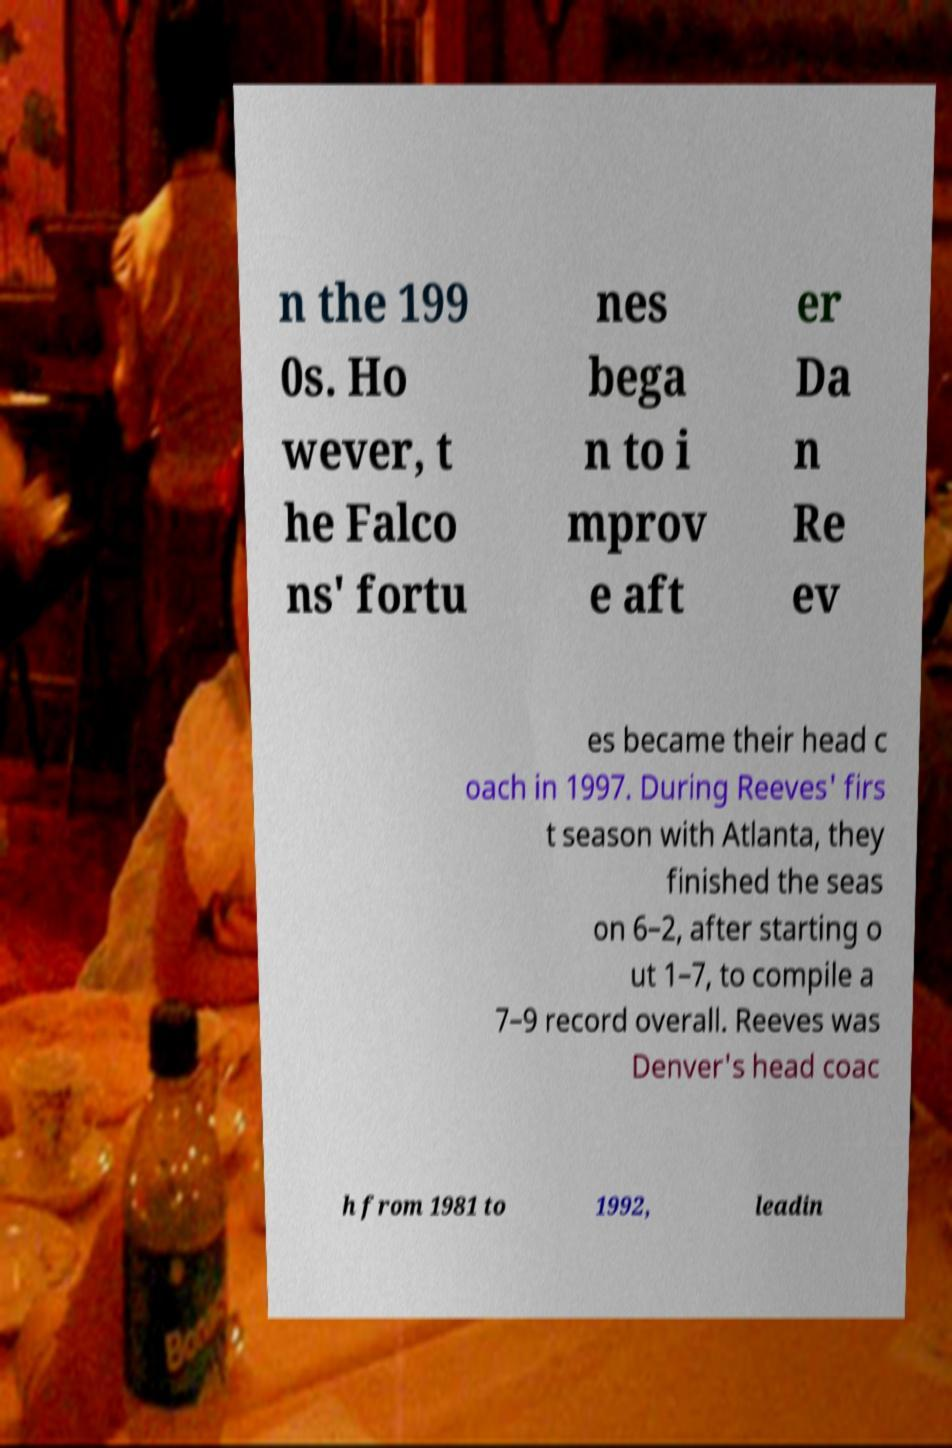There's text embedded in this image that I need extracted. Can you transcribe it verbatim? n the 199 0s. Ho wever, t he Falco ns' fortu nes bega n to i mprov e aft er Da n Re ev es became their head c oach in 1997. During Reeves' firs t season with Atlanta, they finished the seas on 6–2, after starting o ut 1–7, to compile a 7–9 record overall. Reeves was Denver's head coac h from 1981 to 1992, leadin 